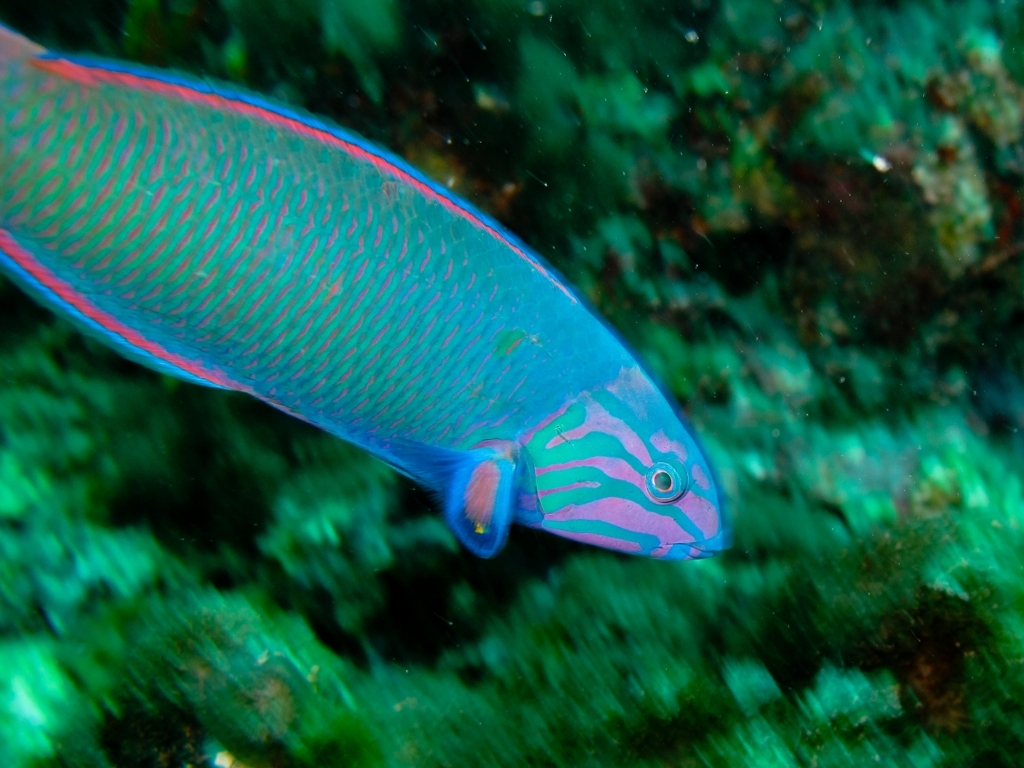Can you provide more details about the creature in the image? Certainly! The image shows a vibrant fish known as a parrotfish, recognizable by its bright colors and patterns. Parrotfish are essential to coral reef ecosystems as they help control algae levels and contribute to the creation of sand through the digestion of coral. What kind of environment does the parrotfish live in? Parrotfish are typically found in shallow tropical and subtropical oceans worldwide, often within coral reefs where they play a crucial role in the health and maintenance of the reef ecosystem. 